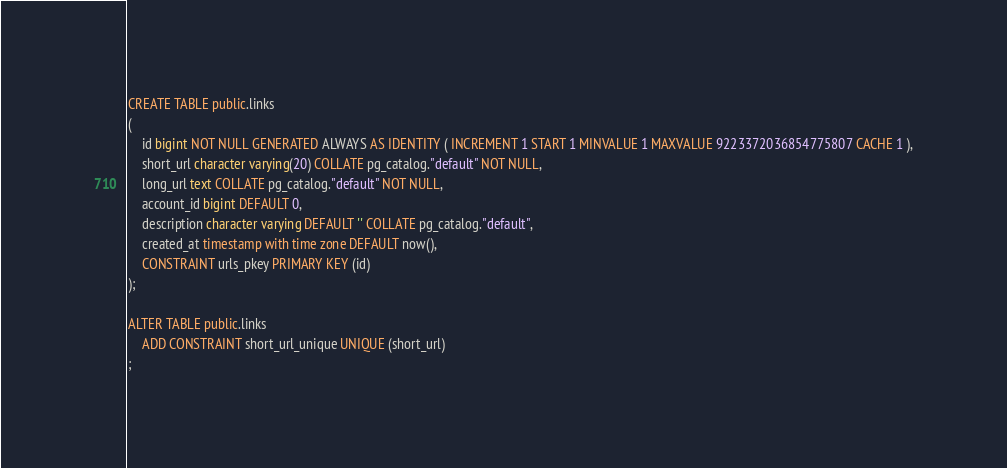Convert code to text. <code><loc_0><loc_0><loc_500><loc_500><_SQL_>CREATE TABLE public.links
(
    id bigint NOT NULL GENERATED ALWAYS AS IDENTITY ( INCREMENT 1 START 1 MINVALUE 1 MAXVALUE 9223372036854775807 CACHE 1 ),
    short_url character varying(20) COLLATE pg_catalog."default" NOT NULL,
    long_url text COLLATE pg_catalog."default" NOT NULL,
    account_id bigint DEFAULT 0,
    description character varying DEFAULT '' COLLATE pg_catalog."default",
    created_at timestamp with time zone DEFAULT now(),
    CONSTRAINT urls_pkey PRIMARY KEY (id)
);

ALTER TABLE public.links
    ADD CONSTRAINT short_url_unique UNIQUE (short_url)
;</code> 